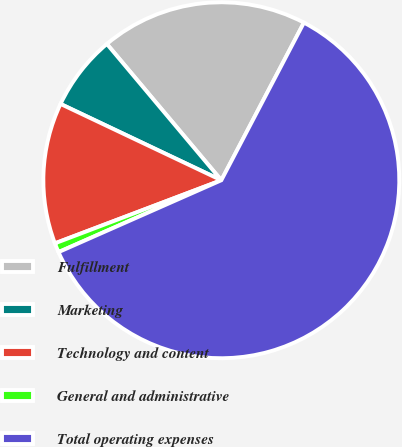Convert chart. <chart><loc_0><loc_0><loc_500><loc_500><pie_chart><fcel>Fulfillment<fcel>Marketing<fcel>Technology and content<fcel>General and administrative<fcel>Total operating expenses<nl><fcel>18.8%<fcel>6.83%<fcel>12.82%<fcel>0.85%<fcel>60.7%<nl></chart> 